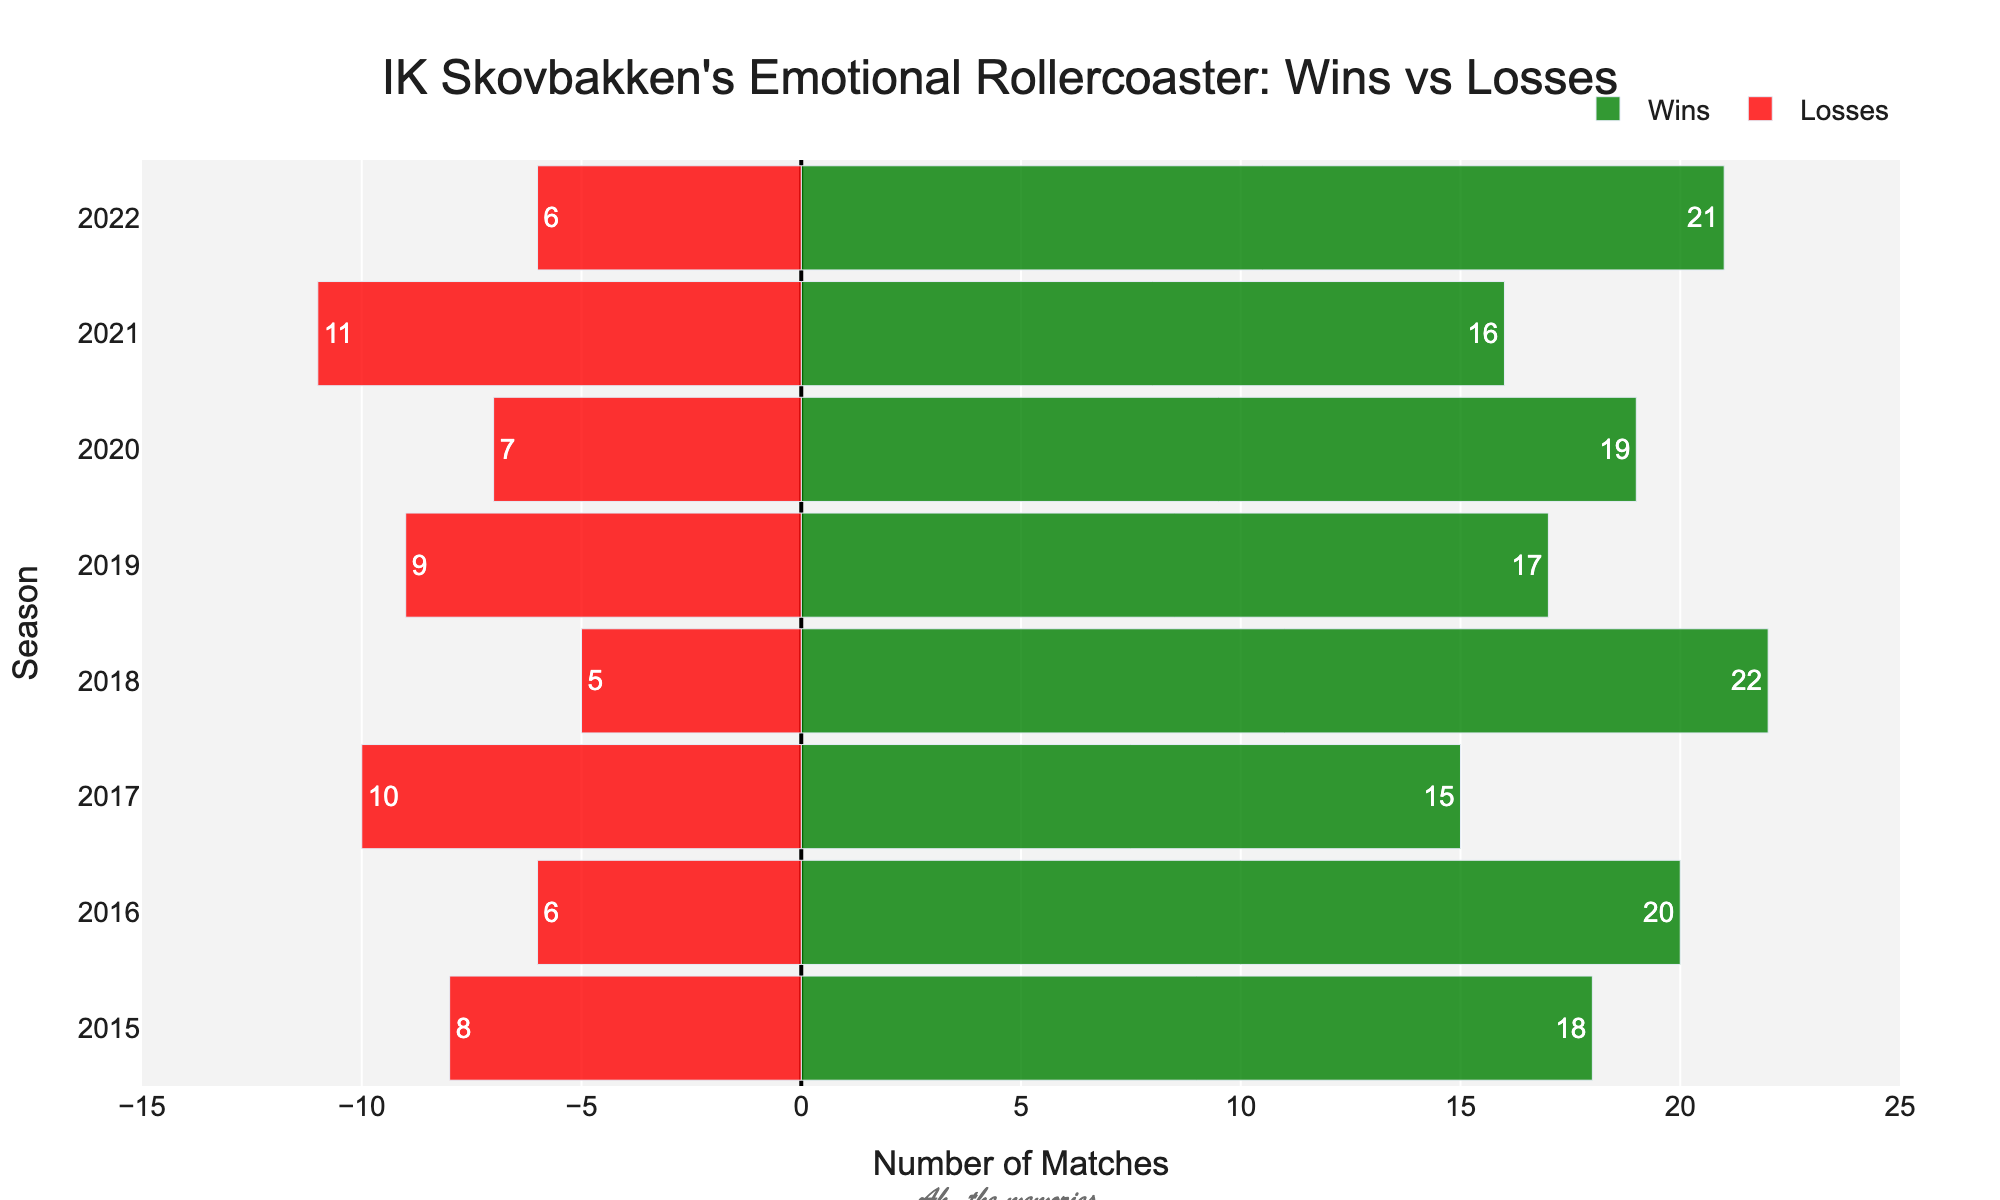What season had the highest number of wins? Looking at the green bars (Positive Win), the longest one is for the 2018 season with 22 wins.
Answer: 2018 In which season did we experience the most losses? Observing the red bars (Negative Loss), the longest one is for the 2021 season with 11 losses.
Answer: 2021 What is the total count of wins and losses in 2020? The 2020 season shows 19 wins and 7 losses, totaling 19 + 7 = 26 matches.
Answer: 26 During which seasons did we have more wins than losses? All seasons have more wins (positive green bars) than losses (negative red bars): 2015, 2016, 2017, 2018, 2019, 2020, 2021, and 2022.
Answer: All seasons How many more wins did we have in 2016 compared to 2017? In 2016, there were 20 wins, and in 2017, there were 15. The difference is 20 - 15 = 5 more wins in 2016 than in 2017.
Answer: 5 What is the average number of wins for the seasons 2015 to 2018? Adding wins for these seasons: 18 + 20 + 15 + 22 = 75. With 4 seasons, the average is 75 / 4 = 18.75.
Answer: 18.75 Which season had the smallest difference between wins and losses? The smallest difference is found in the 2017 season with 15 wins and 10 losses, giving a difference of 15 - 10 = 5.
Answer: 2017 How many total wins are shown over all the seasons? Adding up all the wins: 18 + 20 + 15 + 22 + 17 + 19 + 16 + 21 = 148.
Answer: 148 Which color represents the losses and how are they visually distinguished from wins? Losses are represented by red bars and are shown as negative values extending to the left side.
Answer: Red In which season did we achieve more than 20 wins? The only seasons with more than 20 wins are 2016 (20 wins is not strictly more) and 2018 with 22 wins.
Answer: 2018 